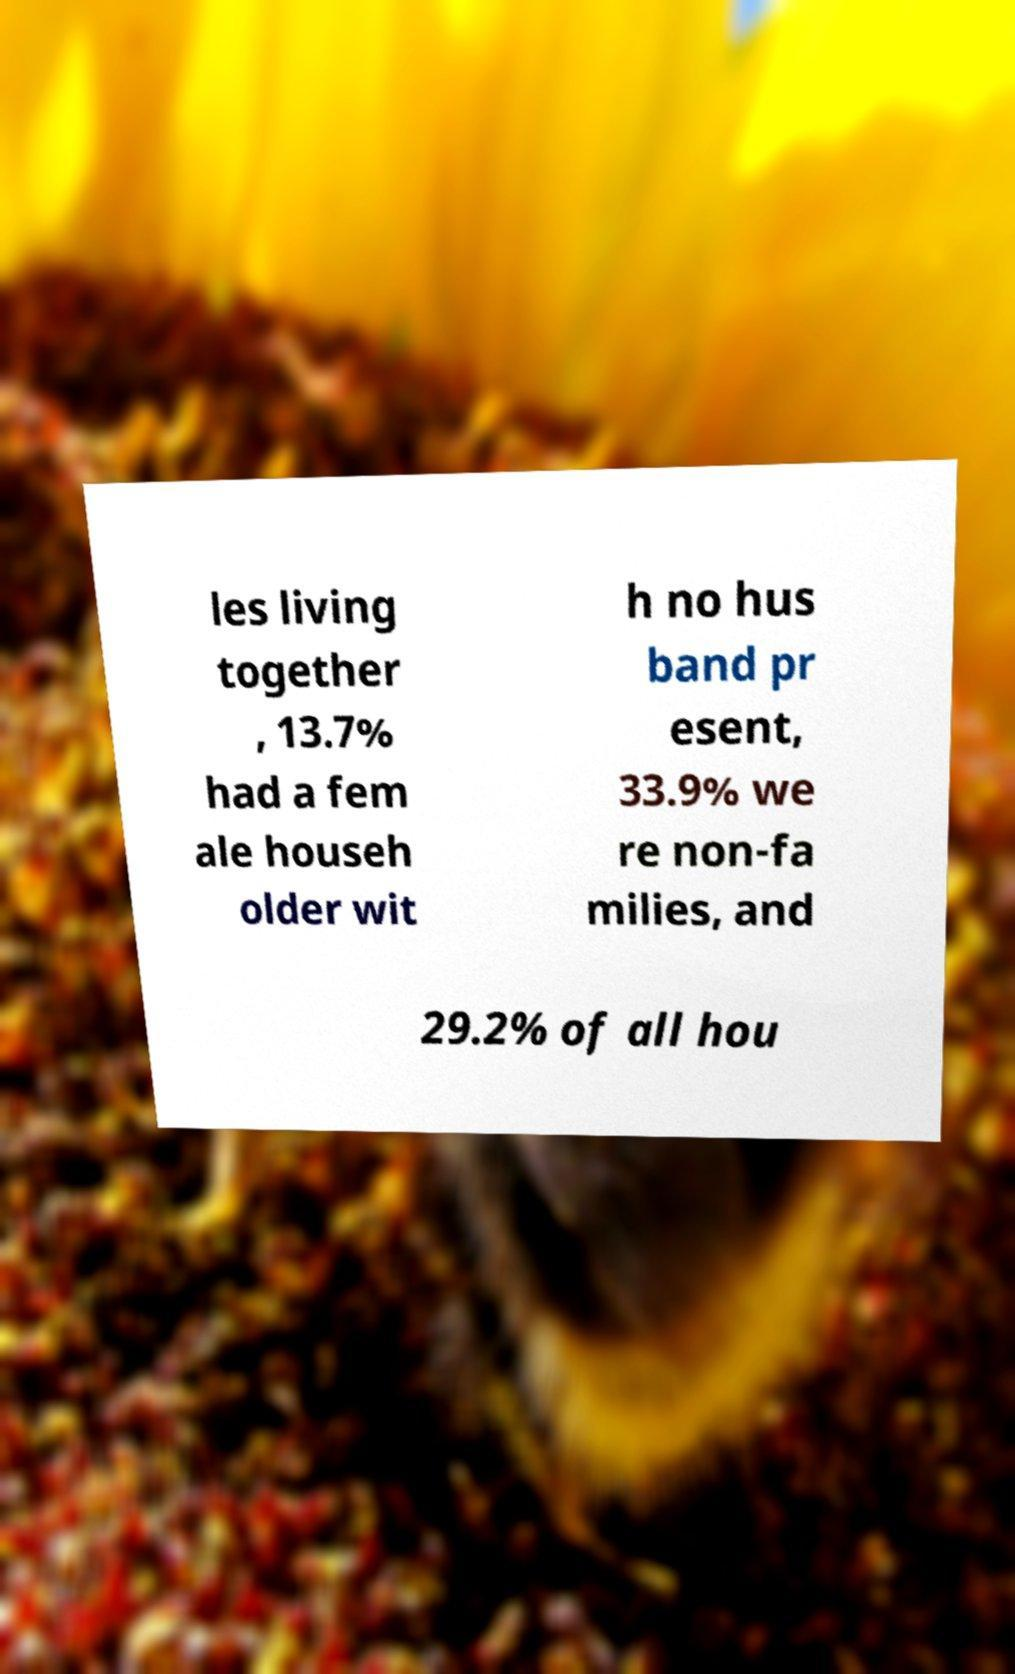I need the written content from this picture converted into text. Can you do that? les living together , 13.7% had a fem ale househ older wit h no hus band pr esent, 33.9% we re non-fa milies, and 29.2% of all hou 